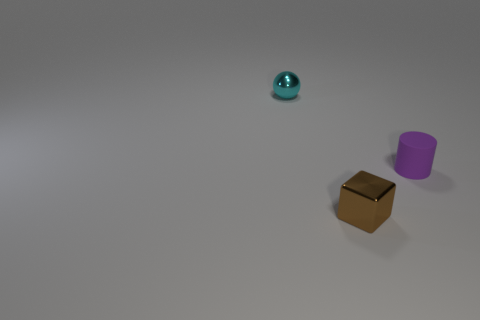Add 1 small shiny balls. How many objects exist? 4 Subtract all cubes. How many objects are left? 2 Add 2 tiny cyan balls. How many tiny cyan balls are left? 3 Add 1 blocks. How many blocks exist? 2 Subtract 0 yellow cylinders. How many objects are left? 3 Subtract all tiny purple matte cylinders. Subtract all metallic objects. How many objects are left? 0 